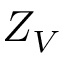Convert formula to latex. <formula><loc_0><loc_0><loc_500><loc_500>Z _ { V }</formula> 